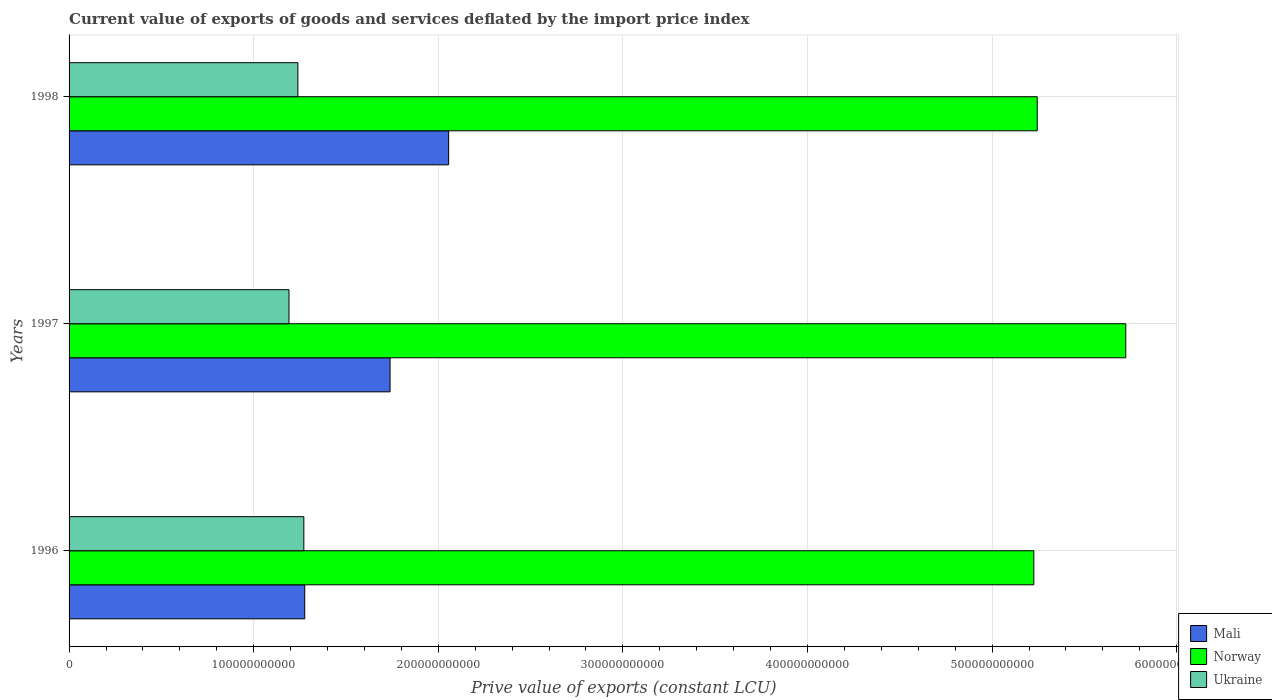How many groups of bars are there?
Keep it short and to the point. 3. Are the number of bars on each tick of the Y-axis equal?
Provide a short and direct response. Yes. How many bars are there on the 1st tick from the top?
Offer a very short reply. 3. How many bars are there on the 1st tick from the bottom?
Keep it short and to the point. 3. What is the label of the 3rd group of bars from the top?
Provide a short and direct response. 1996. What is the prive value of exports in Mali in 1998?
Keep it short and to the point. 2.06e+11. Across all years, what is the maximum prive value of exports in Norway?
Provide a succinct answer. 5.72e+11. Across all years, what is the minimum prive value of exports in Norway?
Offer a very short reply. 5.23e+11. In which year was the prive value of exports in Mali minimum?
Keep it short and to the point. 1996. What is the total prive value of exports in Norway in the graph?
Provide a short and direct response. 1.62e+12. What is the difference between the prive value of exports in Ukraine in 1996 and that in 1997?
Provide a succinct answer. 8.04e+09. What is the difference between the prive value of exports in Ukraine in 1997 and the prive value of exports in Norway in 1998?
Your answer should be compact. -4.05e+11. What is the average prive value of exports in Mali per year?
Your response must be concise. 1.69e+11. In the year 1996, what is the difference between the prive value of exports in Norway and prive value of exports in Ukraine?
Offer a very short reply. 3.95e+11. In how many years, is the prive value of exports in Mali greater than 280000000000 LCU?
Provide a short and direct response. 0. What is the ratio of the prive value of exports in Mali in 1996 to that in 1998?
Your response must be concise. 0.62. Is the prive value of exports in Mali in 1996 less than that in 1997?
Your answer should be very brief. Yes. Is the difference between the prive value of exports in Norway in 1997 and 1998 greater than the difference between the prive value of exports in Ukraine in 1997 and 1998?
Provide a succinct answer. Yes. What is the difference between the highest and the second highest prive value of exports in Ukraine?
Keep it short and to the point. 3.23e+09. What is the difference between the highest and the lowest prive value of exports in Ukraine?
Make the answer very short. 8.04e+09. What does the 2nd bar from the top in 1998 represents?
Offer a terse response. Norway. What does the 3rd bar from the bottom in 1997 represents?
Offer a terse response. Ukraine. Is it the case that in every year, the sum of the prive value of exports in Norway and prive value of exports in Mali is greater than the prive value of exports in Ukraine?
Offer a terse response. Yes. How many bars are there?
Offer a terse response. 9. What is the difference between two consecutive major ticks on the X-axis?
Offer a terse response. 1.00e+11. Are the values on the major ticks of X-axis written in scientific E-notation?
Ensure brevity in your answer.  No. Does the graph contain any zero values?
Give a very brief answer. No. How many legend labels are there?
Your answer should be very brief. 3. How are the legend labels stacked?
Offer a terse response. Vertical. What is the title of the graph?
Make the answer very short. Current value of exports of goods and services deflated by the import price index. Does "Belgium" appear as one of the legend labels in the graph?
Offer a very short reply. No. What is the label or title of the X-axis?
Your response must be concise. Prive value of exports (constant LCU). What is the Prive value of exports (constant LCU) in Mali in 1996?
Provide a short and direct response. 1.28e+11. What is the Prive value of exports (constant LCU) in Norway in 1996?
Ensure brevity in your answer.  5.23e+11. What is the Prive value of exports (constant LCU) of Ukraine in 1996?
Keep it short and to the point. 1.27e+11. What is the Prive value of exports (constant LCU) of Mali in 1997?
Your answer should be very brief. 1.74e+11. What is the Prive value of exports (constant LCU) of Norway in 1997?
Ensure brevity in your answer.  5.72e+11. What is the Prive value of exports (constant LCU) in Ukraine in 1997?
Offer a terse response. 1.19e+11. What is the Prive value of exports (constant LCU) in Mali in 1998?
Offer a terse response. 2.06e+11. What is the Prive value of exports (constant LCU) in Norway in 1998?
Give a very brief answer. 5.24e+11. What is the Prive value of exports (constant LCU) in Ukraine in 1998?
Make the answer very short. 1.24e+11. Across all years, what is the maximum Prive value of exports (constant LCU) in Mali?
Give a very brief answer. 2.06e+11. Across all years, what is the maximum Prive value of exports (constant LCU) of Norway?
Make the answer very short. 5.72e+11. Across all years, what is the maximum Prive value of exports (constant LCU) of Ukraine?
Offer a terse response. 1.27e+11. Across all years, what is the minimum Prive value of exports (constant LCU) in Mali?
Your response must be concise. 1.28e+11. Across all years, what is the minimum Prive value of exports (constant LCU) in Norway?
Your answer should be very brief. 5.23e+11. Across all years, what is the minimum Prive value of exports (constant LCU) in Ukraine?
Offer a very short reply. 1.19e+11. What is the total Prive value of exports (constant LCU) in Mali in the graph?
Your answer should be very brief. 5.07e+11. What is the total Prive value of exports (constant LCU) of Norway in the graph?
Keep it short and to the point. 1.62e+12. What is the total Prive value of exports (constant LCU) of Ukraine in the graph?
Your answer should be compact. 3.70e+11. What is the difference between the Prive value of exports (constant LCU) of Mali in 1996 and that in 1997?
Offer a terse response. -4.62e+1. What is the difference between the Prive value of exports (constant LCU) in Norway in 1996 and that in 1997?
Give a very brief answer. -4.98e+1. What is the difference between the Prive value of exports (constant LCU) of Ukraine in 1996 and that in 1997?
Make the answer very short. 8.04e+09. What is the difference between the Prive value of exports (constant LCU) in Mali in 1996 and that in 1998?
Offer a terse response. -7.79e+1. What is the difference between the Prive value of exports (constant LCU) in Norway in 1996 and that in 1998?
Offer a terse response. -1.85e+09. What is the difference between the Prive value of exports (constant LCU) in Ukraine in 1996 and that in 1998?
Your response must be concise. 3.23e+09. What is the difference between the Prive value of exports (constant LCU) in Mali in 1997 and that in 1998?
Provide a short and direct response. -3.17e+1. What is the difference between the Prive value of exports (constant LCU) of Norway in 1997 and that in 1998?
Ensure brevity in your answer.  4.80e+1. What is the difference between the Prive value of exports (constant LCU) of Ukraine in 1997 and that in 1998?
Ensure brevity in your answer.  -4.81e+09. What is the difference between the Prive value of exports (constant LCU) in Mali in 1996 and the Prive value of exports (constant LCU) in Norway in 1997?
Your answer should be compact. -4.45e+11. What is the difference between the Prive value of exports (constant LCU) in Mali in 1996 and the Prive value of exports (constant LCU) in Ukraine in 1997?
Ensure brevity in your answer.  8.53e+09. What is the difference between the Prive value of exports (constant LCU) of Norway in 1996 and the Prive value of exports (constant LCU) of Ukraine in 1997?
Offer a terse response. 4.03e+11. What is the difference between the Prive value of exports (constant LCU) of Mali in 1996 and the Prive value of exports (constant LCU) of Norway in 1998?
Provide a succinct answer. -3.97e+11. What is the difference between the Prive value of exports (constant LCU) of Mali in 1996 and the Prive value of exports (constant LCU) of Ukraine in 1998?
Your answer should be very brief. 3.72e+09. What is the difference between the Prive value of exports (constant LCU) in Norway in 1996 and the Prive value of exports (constant LCU) in Ukraine in 1998?
Keep it short and to the point. 3.99e+11. What is the difference between the Prive value of exports (constant LCU) in Mali in 1997 and the Prive value of exports (constant LCU) in Norway in 1998?
Give a very brief answer. -3.51e+11. What is the difference between the Prive value of exports (constant LCU) of Mali in 1997 and the Prive value of exports (constant LCU) of Ukraine in 1998?
Your response must be concise. 4.99e+1. What is the difference between the Prive value of exports (constant LCU) of Norway in 1997 and the Prive value of exports (constant LCU) of Ukraine in 1998?
Your answer should be very brief. 4.48e+11. What is the average Prive value of exports (constant LCU) in Mali per year?
Provide a short and direct response. 1.69e+11. What is the average Prive value of exports (constant LCU) of Norway per year?
Offer a terse response. 5.40e+11. What is the average Prive value of exports (constant LCU) in Ukraine per year?
Provide a succinct answer. 1.23e+11. In the year 1996, what is the difference between the Prive value of exports (constant LCU) of Mali and Prive value of exports (constant LCU) of Norway?
Make the answer very short. -3.95e+11. In the year 1996, what is the difference between the Prive value of exports (constant LCU) of Mali and Prive value of exports (constant LCU) of Ukraine?
Give a very brief answer. 4.89e+08. In the year 1996, what is the difference between the Prive value of exports (constant LCU) of Norway and Prive value of exports (constant LCU) of Ukraine?
Your response must be concise. 3.95e+11. In the year 1997, what is the difference between the Prive value of exports (constant LCU) in Mali and Prive value of exports (constant LCU) in Norway?
Your answer should be compact. -3.99e+11. In the year 1997, what is the difference between the Prive value of exports (constant LCU) of Mali and Prive value of exports (constant LCU) of Ukraine?
Offer a terse response. 5.47e+1. In the year 1997, what is the difference between the Prive value of exports (constant LCU) in Norway and Prive value of exports (constant LCU) in Ukraine?
Offer a very short reply. 4.53e+11. In the year 1998, what is the difference between the Prive value of exports (constant LCU) in Mali and Prive value of exports (constant LCU) in Norway?
Offer a terse response. -3.19e+11. In the year 1998, what is the difference between the Prive value of exports (constant LCU) of Mali and Prive value of exports (constant LCU) of Ukraine?
Offer a terse response. 8.17e+1. In the year 1998, what is the difference between the Prive value of exports (constant LCU) in Norway and Prive value of exports (constant LCU) in Ukraine?
Give a very brief answer. 4.01e+11. What is the ratio of the Prive value of exports (constant LCU) in Mali in 1996 to that in 1997?
Make the answer very short. 0.73. What is the ratio of the Prive value of exports (constant LCU) in Norway in 1996 to that in 1997?
Offer a very short reply. 0.91. What is the ratio of the Prive value of exports (constant LCU) in Ukraine in 1996 to that in 1997?
Keep it short and to the point. 1.07. What is the ratio of the Prive value of exports (constant LCU) of Mali in 1996 to that in 1998?
Offer a very short reply. 0.62. What is the ratio of the Prive value of exports (constant LCU) of Ukraine in 1996 to that in 1998?
Your answer should be very brief. 1.03. What is the ratio of the Prive value of exports (constant LCU) in Mali in 1997 to that in 1998?
Make the answer very short. 0.85. What is the ratio of the Prive value of exports (constant LCU) in Norway in 1997 to that in 1998?
Make the answer very short. 1.09. What is the ratio of the Prive value of exports (constant LCU) in Ukraine in 1997 to that in 1998?
Your answer should be compact. 0.96. What is the difference between the highest and the second highest Prive value of exports (constant LCU) of Mali?
Your answer should be compact. 3.17e+1. What is the difference between the highest and the second highest Prive value of exports (constant LCU) in Norway?
Provide a short and direct response. 4.80e+1. What is the difference between the highest and the second highest Prive value of exports (constant LCU) of Ukraine?
Your answer should be compact. 3.23e+09. What is the difference between the highest and the lowest Prive value of exports (constant LCU) of Mali?
Your answer should be very brief. 7.79e+1. What is the difference between the highest and the lowest Prive value of exports (constant LCU) in Norway?
Offer a terse response. 4.98e+1. What is the difference between the highest and the lowest Prive value of exports (constant LCU) of Ukraine?
Offer a terse response. 8.04e+09. 